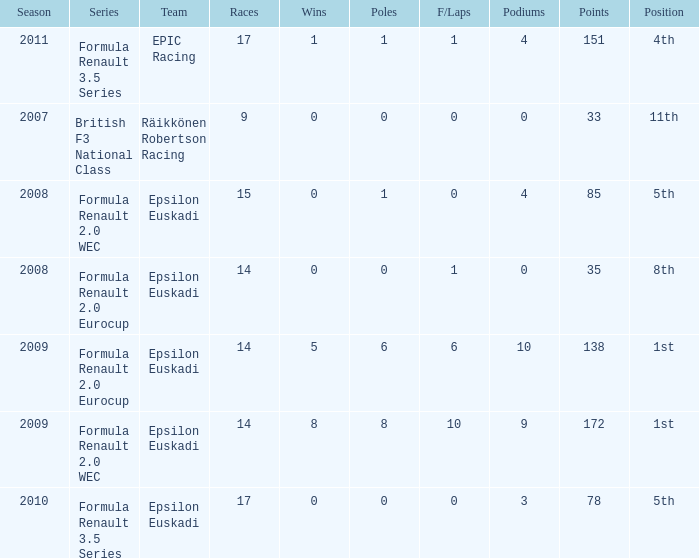What team was he on when he had 10 f/laps? Epsilon Euskadi. 